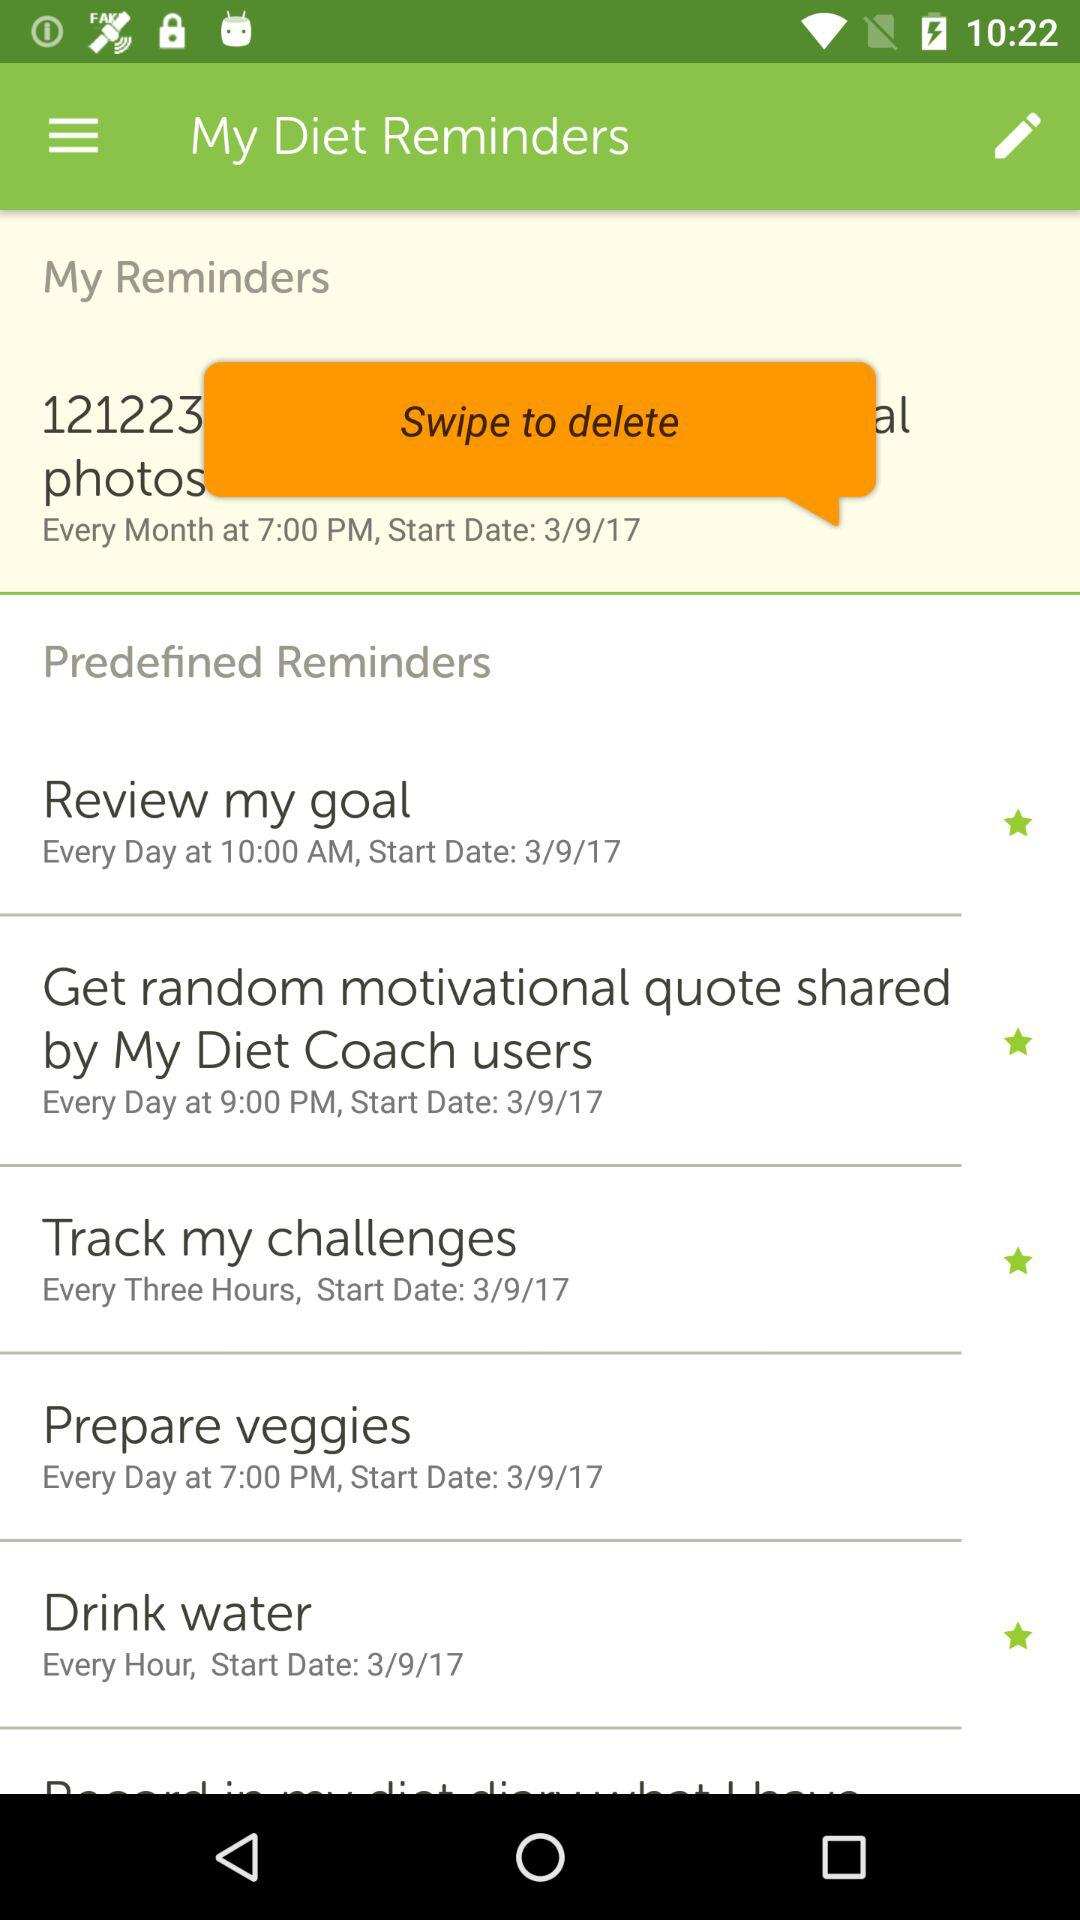What is the start date for drinking water? The start date for drinking water is March 9, 2017. 